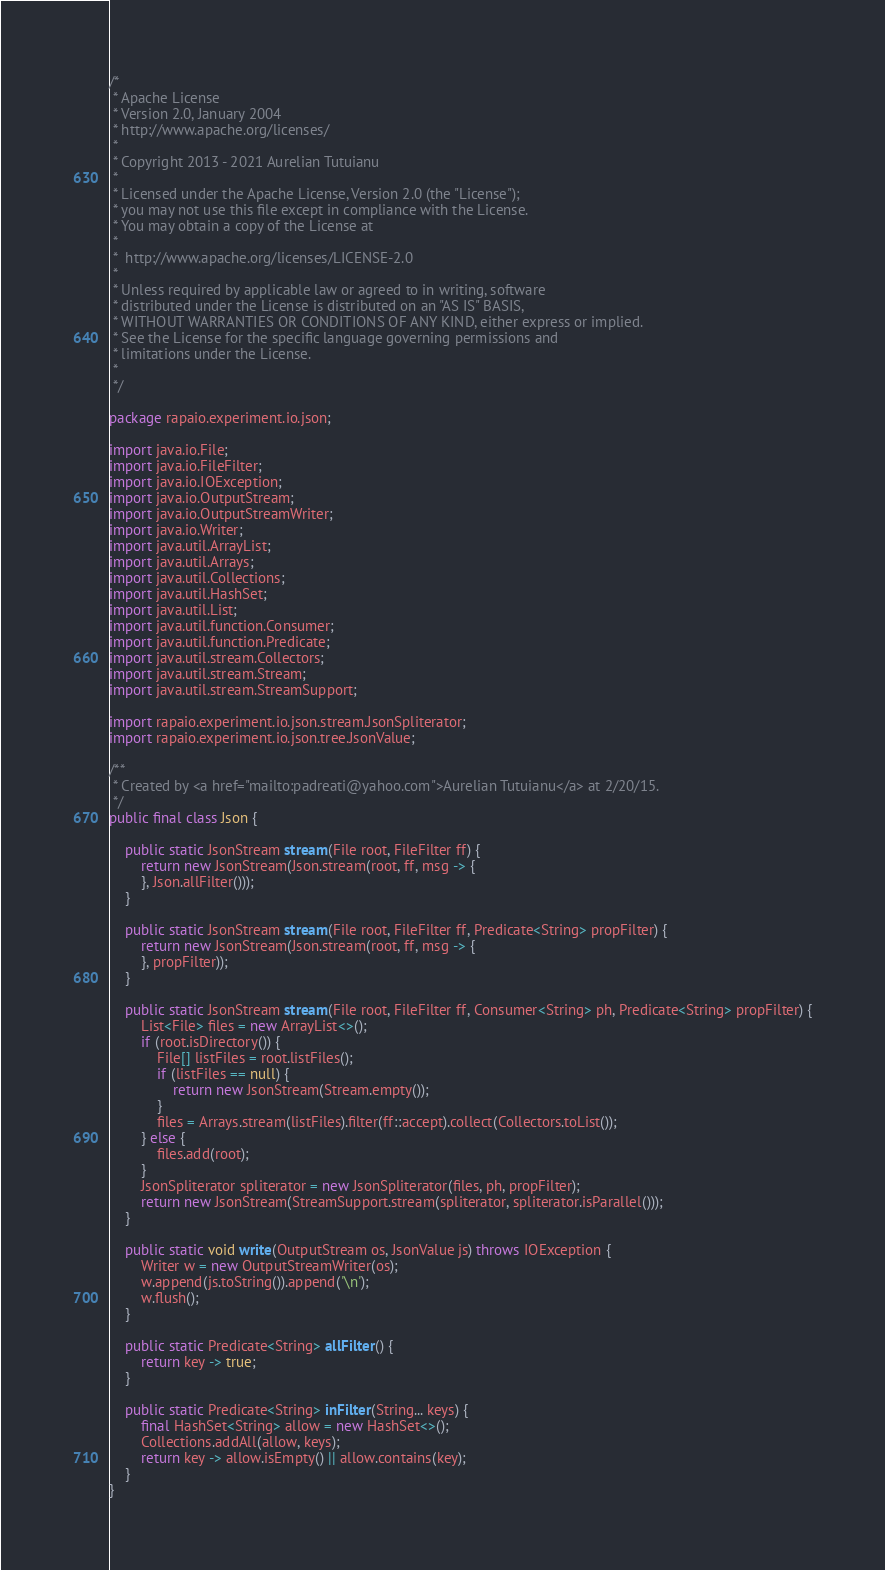Convert code to text. <code><loc_0><loc_0><loc_500><loc_500><_Java_>/*
 * Apache License
 * Version 2.0, January 2004
 * http://www.apache.org/licenses/
 *
 * Copyright 2013 - 2021 Aurelian Tutuianu
 *
 * Licensed under the Apache License, Version 2.0 (the "License");
 * you may not use this file except in compliance with the License.
 * You may obtain a copy of the License at
 *
 *  http://www.apache.org/licenses/LICENSE-2.0
 *
 * Unless required by applicable law or agreed to in writing, software
 * distributed under the License is distributed on an "AS IS" BASIS,
 * WITHOUT WARRANTIES OR CONDITIONS OF ANY KIND, either express or implied.
 * See the License for the specific language governing permissions and
 * limitations under the License.
 *
 */

package rapaio.experiment.io.json;

import java.io.File;
import java.io.FileFilter;
import java.io.IOException;
import java.io.OutputStream;
import java.io.OutputStreamWriter;
import java.io.Writer;
import java.util.ArrayList;
import java.util.Arrays;
import java.util.Collections;
import java.util.HashSet;
import java.util.List;
import java.util.function.Consumer;
import java.util.function.Predicate;
import java.util.stream.Collectors;
import java.util.stream.Stream;
import java.util.stream.StreamSupport;

import rapaio.experiment.io.json.stream.JsonSpliterator;
import rapaio.experiment.io.json.tree.JsonValue;

/**
 * Created by <a href="mailto:padreati@yahoo.com">Aurelian Tutuianu</a> at 2/20/15.
 */
public final class Json {

    public static JsonStream stream(File root, FileFilter ff) {
        return new JsonStream(Json.stream(root, ff, msg -> {
        }, Json.allFilter()));
    }

    public static JsonStream stream(File root, FileFilter ff, Predicate<String> propFilter) {
        return new JsonStream(Json.stream(root, ff, msg -> {
        }, propFilter));
    }

    public static JsonStream stream(File root, FileFilter ff, Consumer<String> ph, Predicate<String> propFilter) {
        List<File> files = new ArrayList<>();
        if (root.isDirectory()) {
            File[] listFiles = root.listFiles();
            if (listFiles == null) {
                return new JsonStream(Stream.empty());
            }
            files = Arrays.stream(listFiles).filter(ff::accept).collect(Collectors.toList());
        } else {
            files.add(root);
        }
        JsonSpliterator spliterator = new JsonSpliterator(files, ph, propFilter);
        return new JsonStream(StreamSupport.stream(spliterator, spliterator.isParallel()));
    }

    public static void write(OutputStream os, JsonValue js) throws IOException {
        Writer w = new OutputStreamWriter(os);
        w.append(js.toString()).append('\n');
        w.flush();
    }

    public static Predicate<String> allFilter() {
        return key -> true;
    }

    public static Predicate<String> inFilter(String... keys) {
        final HashSet<String> allow = new HashSet<>();
        Collections.addAll(allow, keys);
        return key -> allow.isEmpty() || allow.contains(key);
    }
}
</code> 